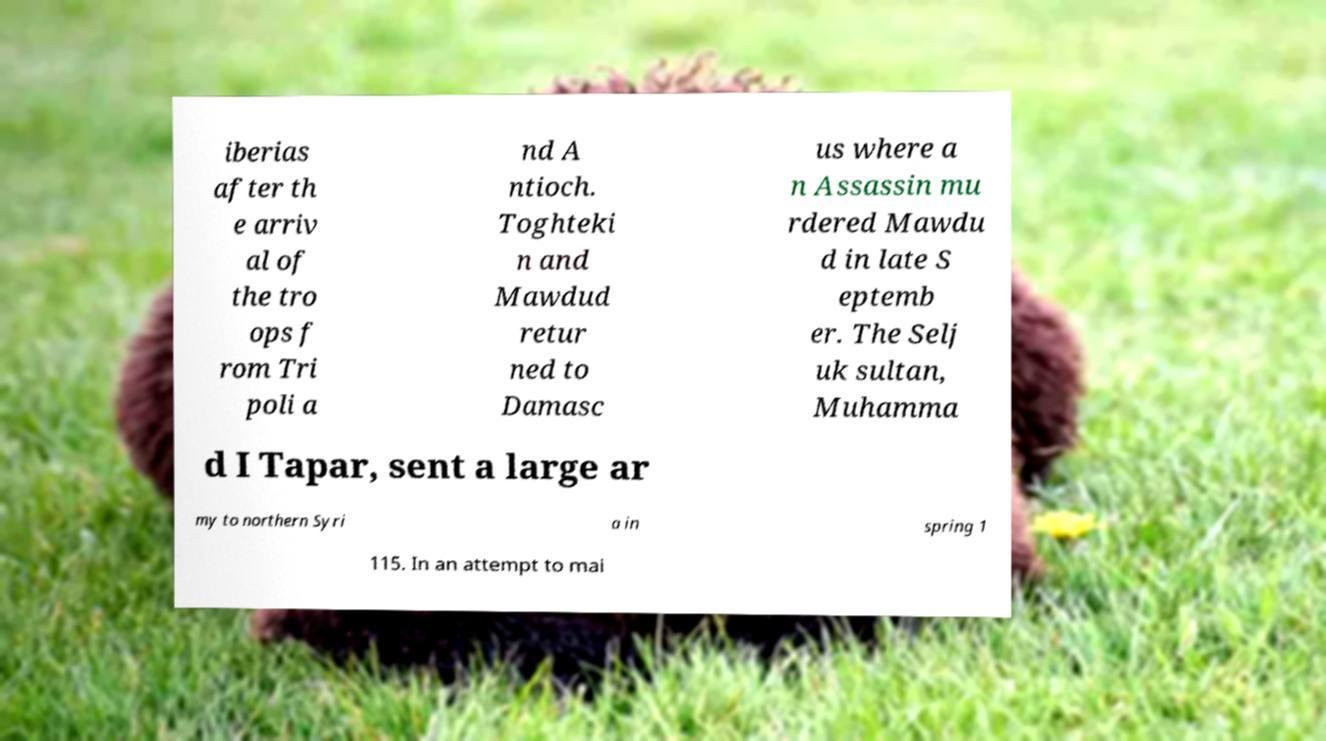Please identify and transcribe the text found in this image. iberias after th e arriv al of the tro ops f rom Tri poli a nd A ntioch. Toghteki n and Mawdud retur ned to Damasc us where a n Assassin mu rdered Mawdu d in late S eptemb er. The Selj uk sultan, Muhamma d I Tapar, sent a large ar my to northern Syri a in spring 1 115. In an attempt to mai 